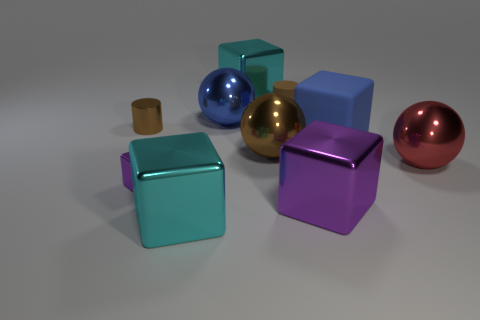What can you tell me about the lighting and shadows in the scene? The lighting in this scene is soft and diffuse, creating gentle shadows that extend away from the objects. This suggests an overhead or possibly multiple light sources inducing wider, less-defined shadows. The softness of the shadows helps to accentuate the objects' shapes by giving them a subtle depth without creating overly harsh contrasts. It adds to the calm and clean aesthetic of the setup. 